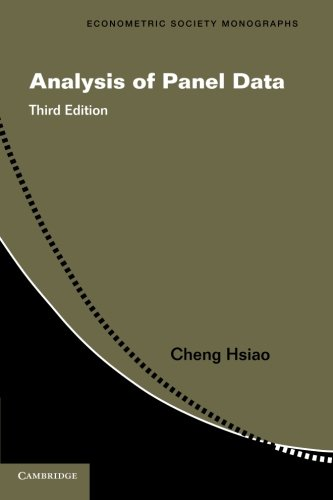Is this book related to Engineering & Transportation? No, this book centers on econometric and statistical analysis in the field of economics and does not delve into engineering or transportation topics. 